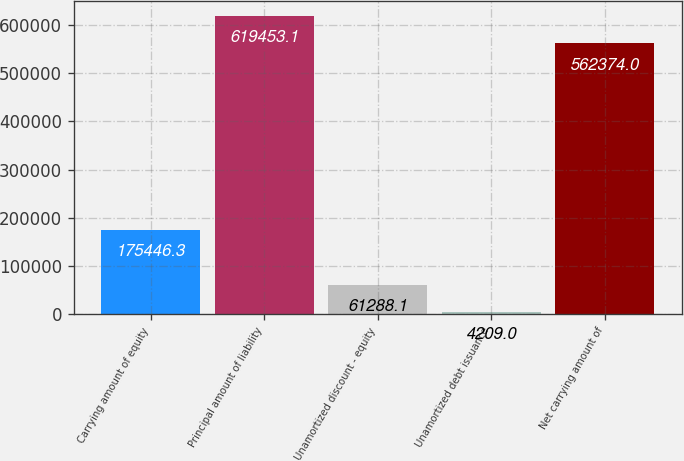<chart> <loc_0><loc_0><loc_500><loc_500><bar_chart><fcel>Carrying amount of equity<fcel>Principal amount of liability<fcel>Unamortized discount - equity<fcel>Unamortized debt issuance<fcel>Net carrying amount of<nl><fcel>175446<fcel>619453<fcel>61288.1<fcel>4209<fcel>562374<nl></chart> 